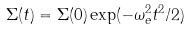Convert formula to latex. <formula><loc_0><loc_0><loc_500><loc_500>\Sigma ( t ) = \Sigma ( 0 ) \exp ( - \omega _ { e } ^ { 2 } t ^ { 2 } / 2 )</formula> 